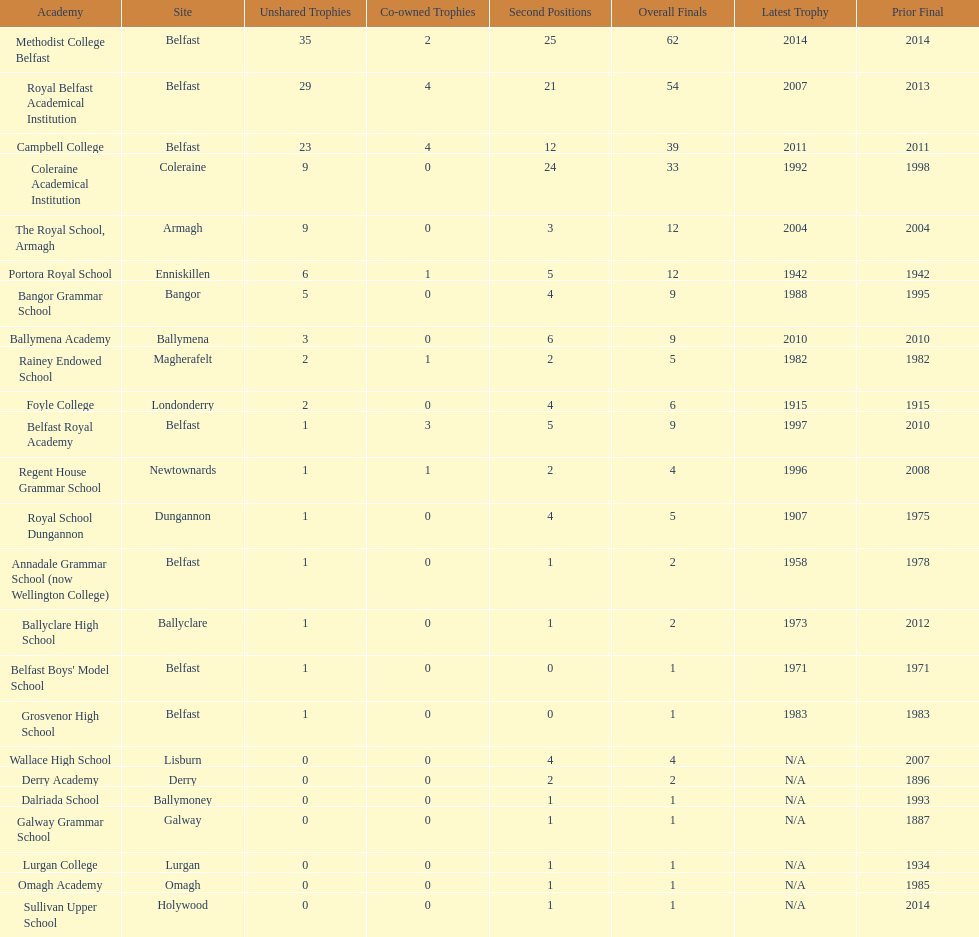Which school has the same number of outright titles as the coleraine academical institution? The Royal School, Armagh. 